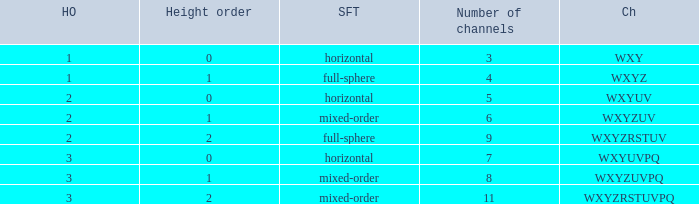If the channels is wxyzuv, what is the number of channels? 6.0. 